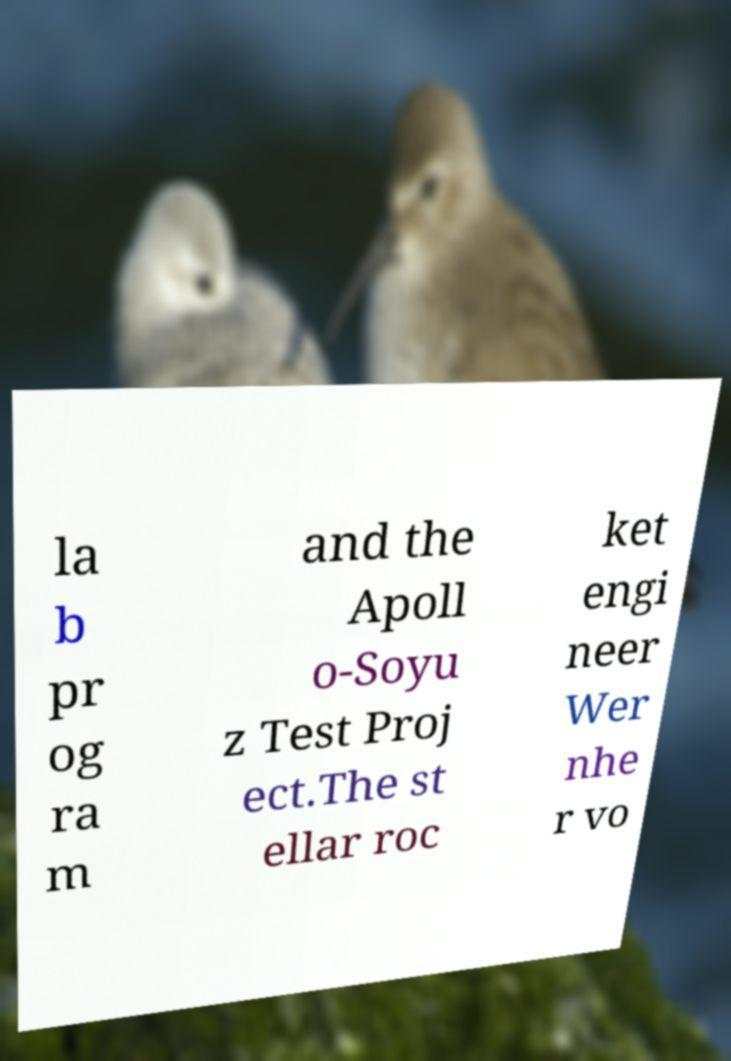Can you accurately transcribe the text from the provided image for me? la b pr og ra m and the Apoll o-Soyu z Test Proj ect.The st ellar roc ket engi neer Wer nhe r vo 